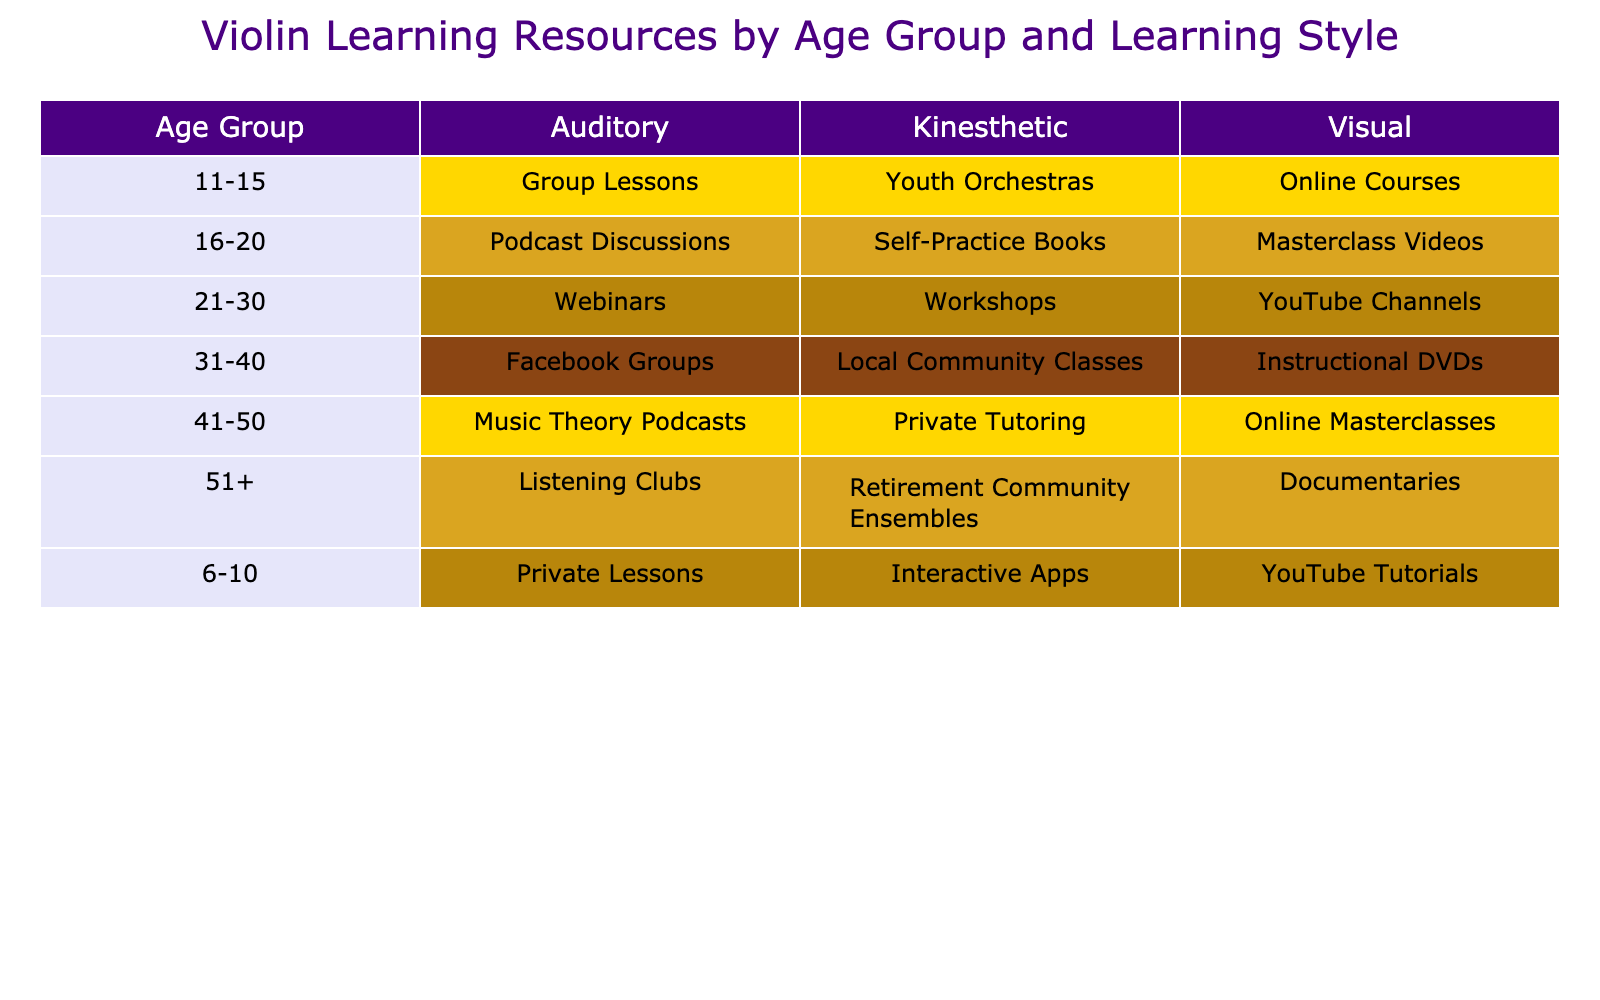What resource do the 6-10 age group prefer when learning visually? The table specifies the learning styles and resources, and for the 6-10 age group under the visual category, the resource mentioned is YouTube Tutorials.
Answer: YouTube Tutorials Which learning style has the highest variety of resources for the 31-40 age group? For the 31-40 age group, the learning styles listed are Visual, Auditory, and Kinesthetic. Each of these styles has one corresponding resource: Instructional DVDs, Facebook Groups, and Local Community Classes respectively. Therefore, the variety of resources is the same across all three learning styles.
Answer: All have the same variety Is there a Kinesthetic resource listed for the 41-50 age group? In the 41-50 age group, the table shows a Kinesthetic resource, which is Private Tutoring. Thus, the answer is yes.
Answer: Yes What is the total number of resources used by the 16-20 age group? The 16-20 age group has three learning styles listed: Visual (Masterclass Videos), Auditory (Podcast Discussions), and Kinesthetic (Self-Practice Books). Adding these together gives a total of three resources.
Answer: 3 For the age group 51+, what learning style corresponds to the Listening Clubs resource? According to the table, the Listening Clubs resource corresponds to the Auditory learning style for the age group 51+.
Answer: Auditory Which age group favors workshops the most? The table indicates that the 21-30 age group has workshops listed under the Kinesthetic learning style, thus showing that this age group favors workshops the most.
Answer: 21-30 What is the difference in the number of resources between the Visual and Kinesthetic styles for the 11-15 age group? The Visual style for the 11-15 age group has one resource (Online Courses), while the Kinesthetic style has one resource as well (Youth Orchestras), which shows no difference as both have 1 resource.
Answer: 0 Are there any age groups that prefer online courses for their learning? The only age group that prefers online courses is the 11-15 age group, as this is the only group listed with this resource under the Visual learning style. Therefore, the answer is yes.
Answer: Yes In total, how many resources does the 21-30 age group utilize compared to the 31-40 age group? The 21-30 age group has three resources: YouTube Channels, Webinars, and Workshops. The 31-40 age group also has three resources: Instructional DVDs, Facebook Groups, and Local Community Classes. Thus, both age groups have an equal number of resources.
Answer: Equal (3 each) 